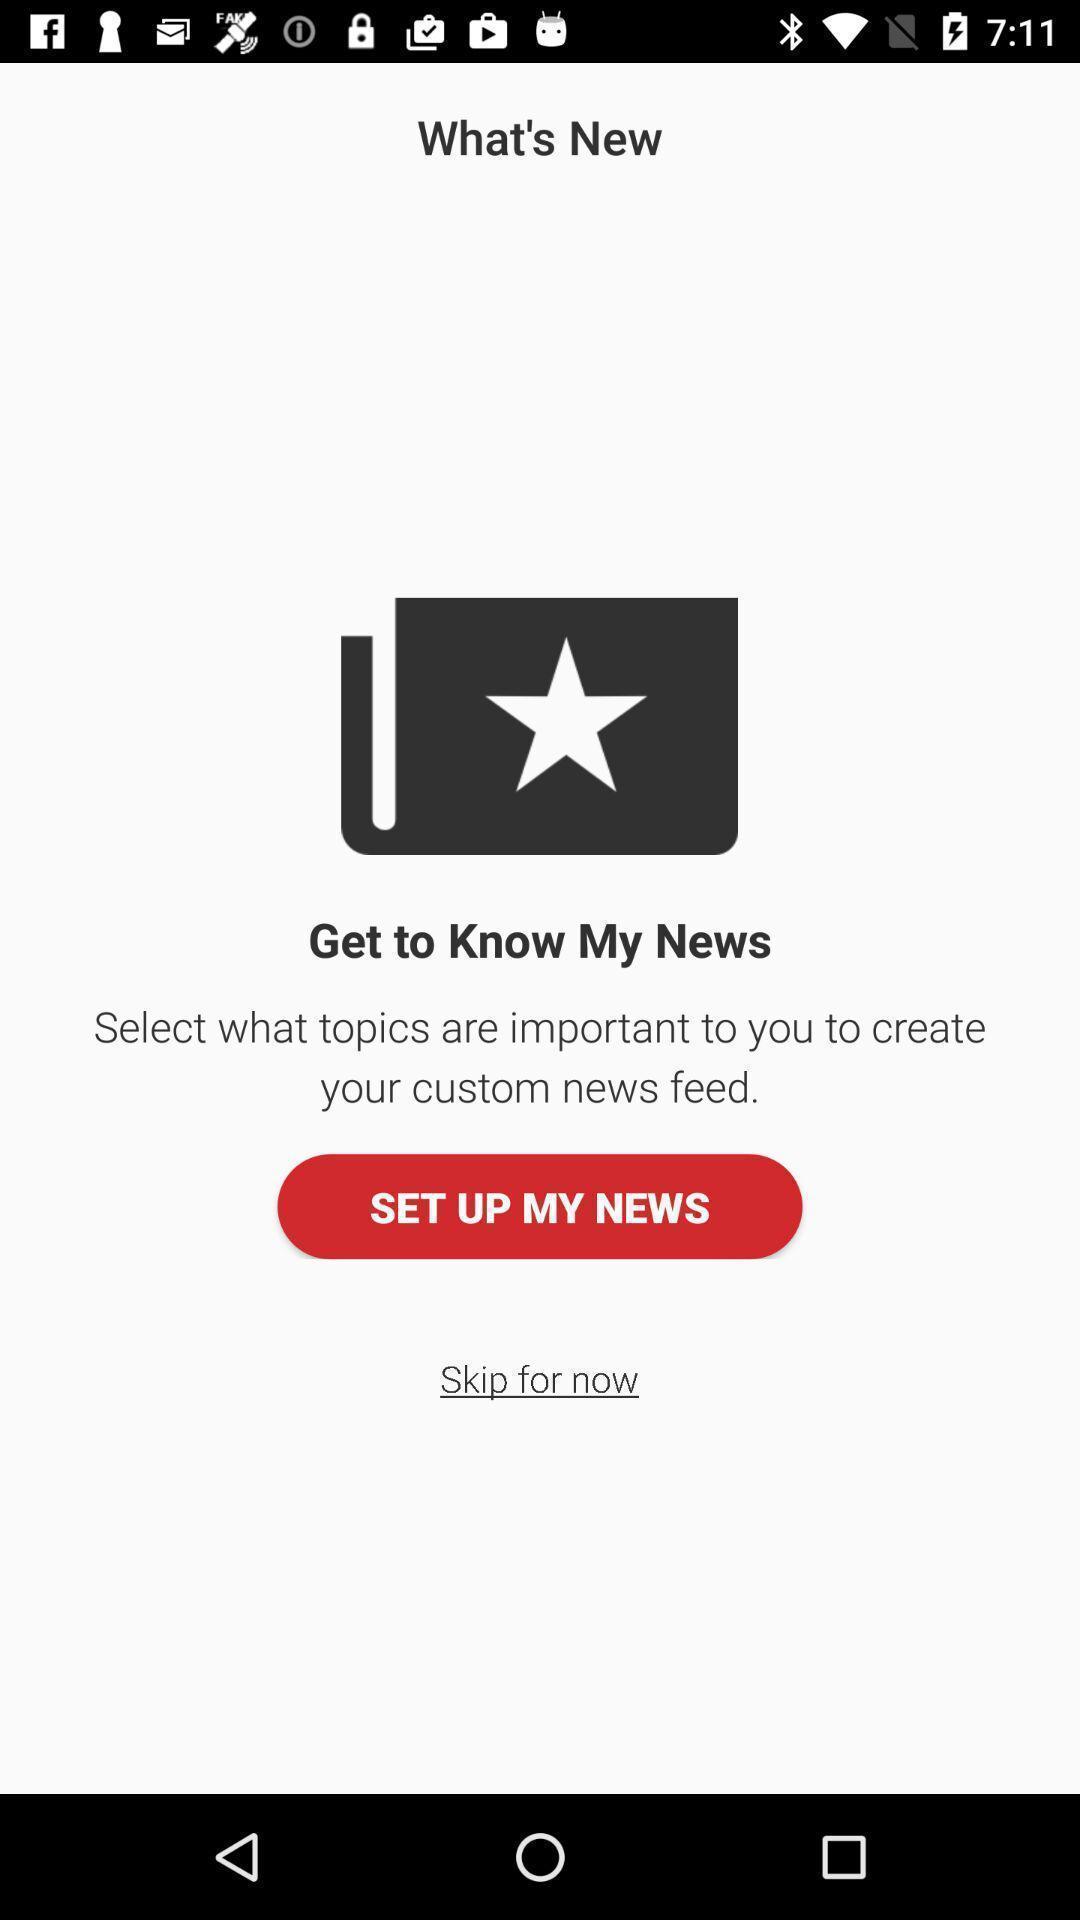Describe the visual elements of this screenshot. Welcome page to set up news displayed in news app. 